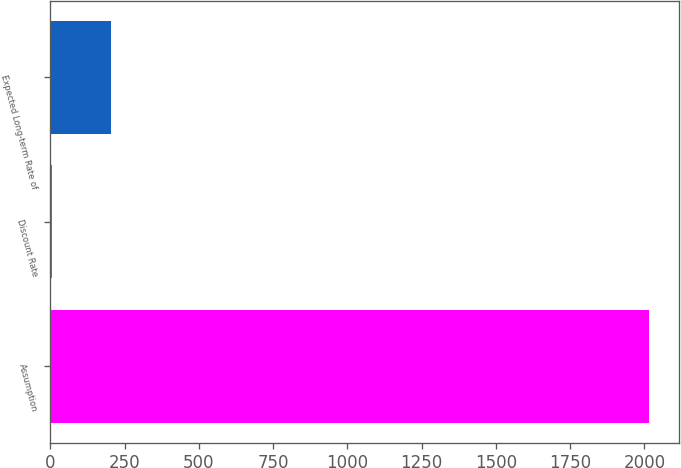<chart> <loc_0><loc_0><loc_500><loc_500><bar_chart><fcel>Assumption<fcel>Discount Rate<fcel>Expected Long-term Rate of<nl><fcel>2016<fcel>4.8<fcel>205.92<nl></chart> 